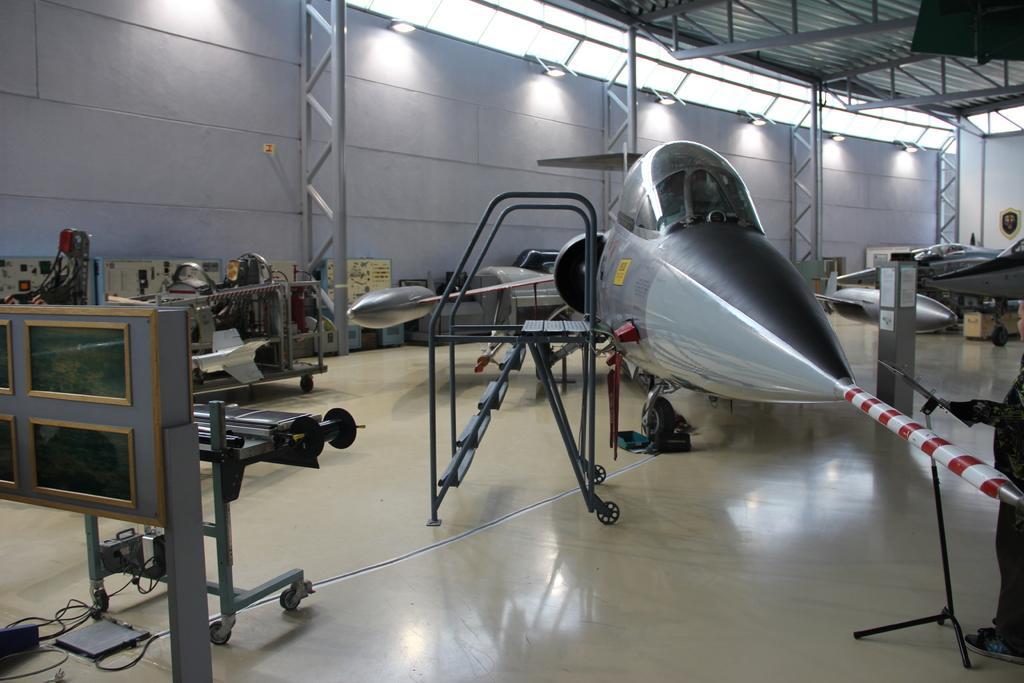Could you give a brief overview of what you see in this image? In this image we can see the inner view of a room. In the room we can see walls, electric lights, iron grills, spare parts, ladder and air crafts. 